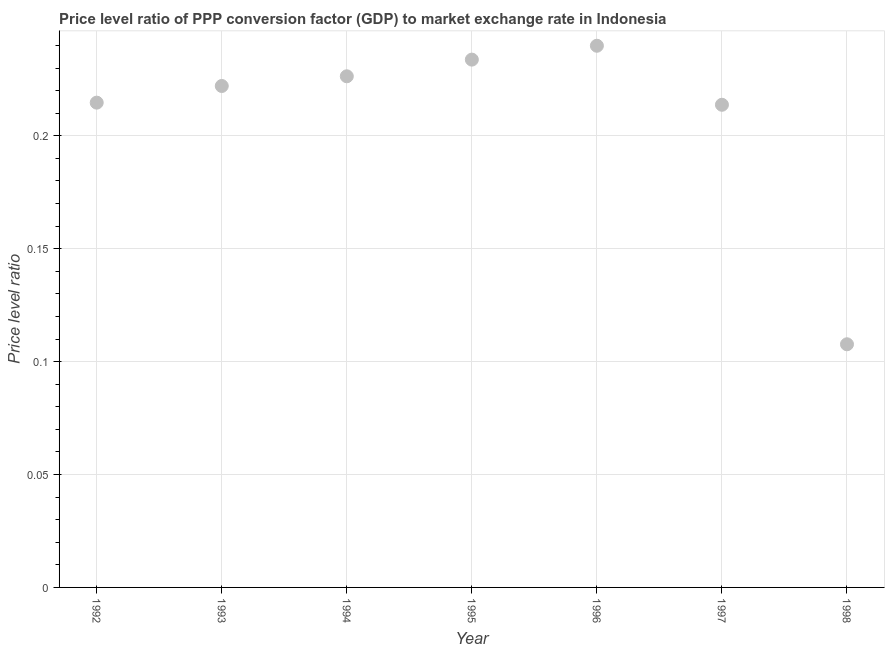What is the price level ratio in 1993?
Give a very brief answer. 0.22. Across all years, what is the maximum price level ratio?
Ensure brevity in your answer.  0.24. Across all years, what is the minimum price level ratio?
Offer a terse response. 0.11. In which year was the price level ratio minimum?
Your answer should be compact. 1998. What is the sum of the price level ratio?
Your answer should be very brief. 1.46. What is the difference between the price level ratio in 1992 and 1994?
Offer a very short reply. -0.01. What is the average price level ratio per year?
Ensure brevity in your answer.  0.21. What is the median price level ratio?
Give a very brief answer. 0.22. What is the ratio of the price level ratio in 1995 to that in 1998?
Your answer should be very brief. 2.17. Is the price level ratio in 1993 less than that in 1998?
Your answer should be very brief. No. What is the difference between the highest and the second highest price level ratio?
Offer a terse response. 0.01. Is the sum of the price level ratio in 1992 and 1994 greater than the maximum price level ratio across all years?
Ensure brevity in your answer.  Yes. What is the difference between the highest and the lowest price level ratio?
Your response must be concise. 0.13. How many dotlines are there?
Give a very brief answer. 1. How many years are there in the graph?
Make the answer very short. 7. What is the difference between two consecutive major ticks on the Y-axis?
Provide a short and direct response. 0.05. Are the values on the major ticks of Y-axis written in scientific E-notation?
Your answer should be compact. No. What is the title of the graph?
Ensure brevity in your answer.  Price level ratio of PPP conversion factor (GDP) to market exchange rate in Indonesia. What is the label or title of the X-axis?
Your answer should be very brief. Year. What is the label or title of the Y-axis?
Make the answer very short. Price level ratio. What is the Price level ratio in 1992?
Offer a terse response. 0.21. What is the Price level ratio in 1993?
Your response must be concise. 0.22. What is the Price level ratio in 1994?
Offer a very short reply. 0.23. What is the Price level ratio in 1995?
Provide a short and direct response. 0.23. What is the Price level ratio in 1996?
Give a very brief answer. 0.24. What is the Price level ratio in 1997?
Give a very brief answer. 0.21. What is the Price level ratio in 1998?
Give a very brief answer. 0.11. What is the difference between the Price level ratio in 1992 and 1993?
Your answer should be compact. -0.01. What is the difference between the Price level ratio in 1992 and 1994?
Make the answer very short. -0.01. What is the difference between the Price level ratio in 1992 and 1995?
Give a very brief answer. -0.02. What is the difference between the Price level ratio in 1992 and 1996?
Ensure brevity in your answer.  -0.03. What is the difference between the Price level ratio in 1992 and 1997?
Your answer should be compact. 0. What is the difference between the Price level ratio in 1992 and 1998?
Provide a short and direct response. 0.11. What is the difference between the Price level ratio in 1993 and 1994?
Provide a succinct answer. -0. What is the difference between the Price level ratio in 1993 and 1995?
Keep it short and to the point. -0.01. What is the difference between the Price level ratio in 1993 and 1996?
Your answer should be compact. -0.02. What is the difference between the Price level ratio in 1993 and 1997?
Keep it short and to the point. 0.01. What is the difference between the Price level ratio in 1993 and 1998?
Provide a short and direct response. 0.11. What is the difference between the Price level ratio in 1994 and 1995?
Your answer should be compact. -0.01. What is the difference between the Price level ratio in 1994 and 1996?
Provide a short and direct response. -0.01. What is the difference between the Price level ratio in 1994 and 1997?
Your response must be concise. 0.01. What is the difference between the Price level ratio in 1994 and 1998?
Give a very brief answer. 0.12. What is the difference between the Price level ratio in 1995 and 1996?
Provide a short and direct response. -0.01. What is the difference between the Price level ratio in 1995 and 1998?
Provide a short and direct response. 0.13. What is the difference between the Price level ratio in 1996 and 1997?
Your answer should be compact. 0.03. What is the difference between the Price level ratio in 1996 and 1998?
Keep it short and to the point. 0.13. What is the difference between the Price level ratio in 1997 and 1998?
Make the answer very short. 0.11. What is the ratio of the Price level ratio in 1992 to that in 1993?
Make the answer very short. 0.97. What is the ratio of the Price level ratio in 1992 to that in 1994?
Provide a succinct answer. 0.95. What is the ratio of the Price level ratio in 1992 to that in 1995?
Your response must be concise. 0.92. What is the ratio of the Price level ratio in 1992 to that in 1996?
Your answer should be compact. 0.9. What is the ratio of the Price level ratio in 1992 to that in 1998?
Your response must be concise. 1.99. What is the ratio of the Price level ratio in 1993 to that in 1995?
Your answer should be compact. 0.95. What is the ratio of the Price level ratio in 1993 to that in 1996?
Offer a terse response. 0.93. What is the ratio of the Price level ratio in 1993 to that in 1997?
Keep it short and to the point. 1.04. What is the ratio of the Price level ratio in 1993 to that in 1998?
Provide a short and direct response. 2.06. What is the ratio of the Price level ratio in 1994 to that in 1996?
Offer a very short reply. 0.94. What is the ratio of the Price level ratio in 1994 to that in 1997?
Your answer should be compact. 1.06. What is the ratio of the Price level ratio in 1994 to that in 1998?
Give a very brief answer. 2.1. What is the ratio of the Price level ratio in 1995 to that in 1997?
Make the answer very short. 1.09. What is the ratio of the Price level ratio in 1995 to that in 1998?
Give a very brief answer. 2.17. What is the ratio of the Price level ratio in 1996 to that in 1997?
Your answer should be very brief. 1.12. What is the ratio of the Price level ratio in 1996 to that in 1998?
Your response must be concise. 2.23. What is the ratio of the Price level ratio in 1997 to that in 1998?
Ensure brevity in your answer.  1.99. 